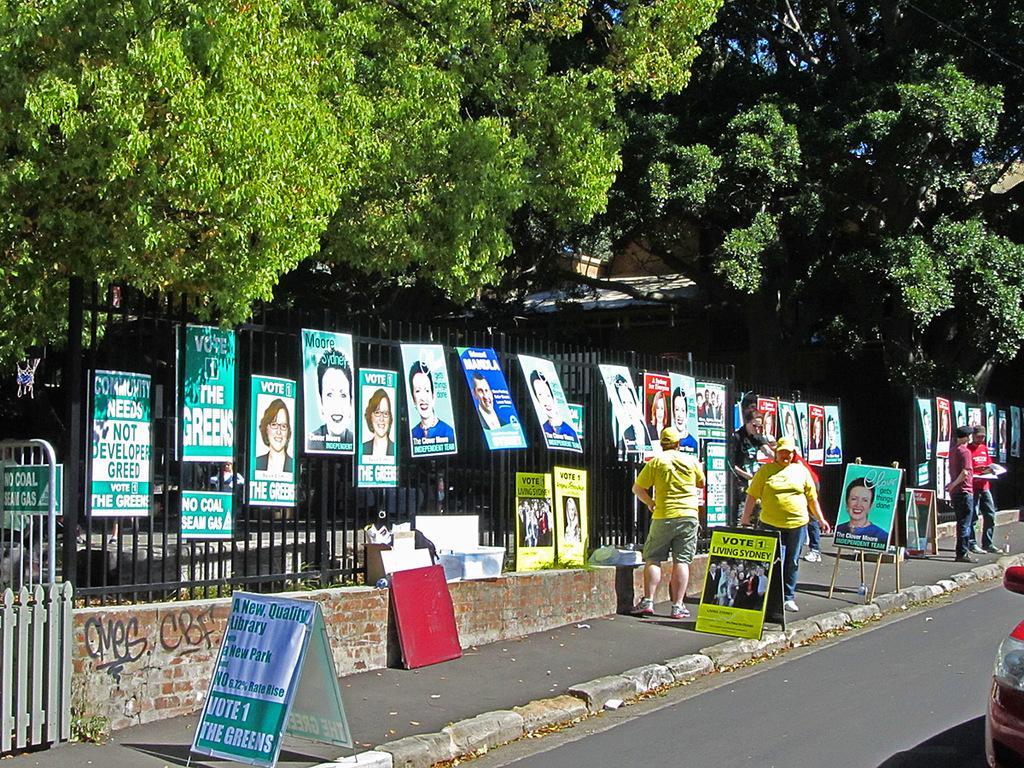Could you give a brief overview of what you see in this image? In this picture we can see a group of people on the path and on the path there are boards. Behind the people there is a fence and on the fence there are boards. Behind the fence there are trees, house and a sky. 